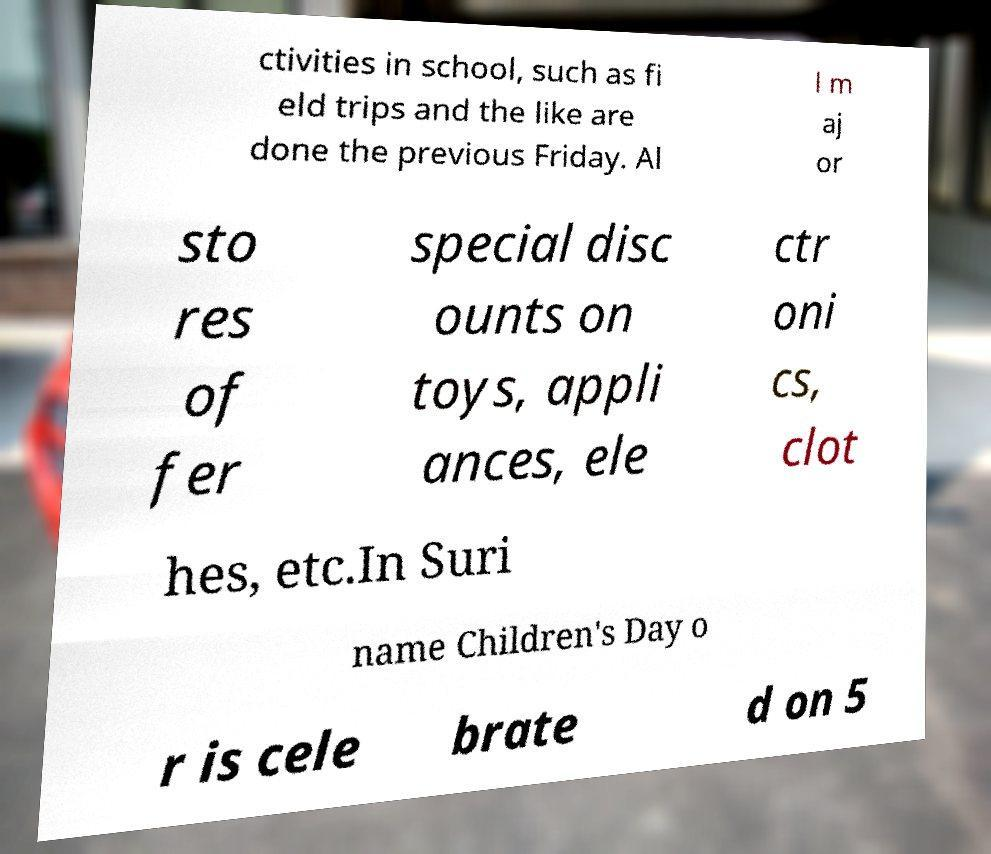I need the written content from this picture converted into text. Can you do that? ctivities in school, such as fi eld trips and the like are done the previous Friday. Al l m aj or sto res of fer special disc ounts on toys, appli ances, ele ctr oni cs, clot hes, etc.In Suri name Children's Day o r is cele brate d on 5 